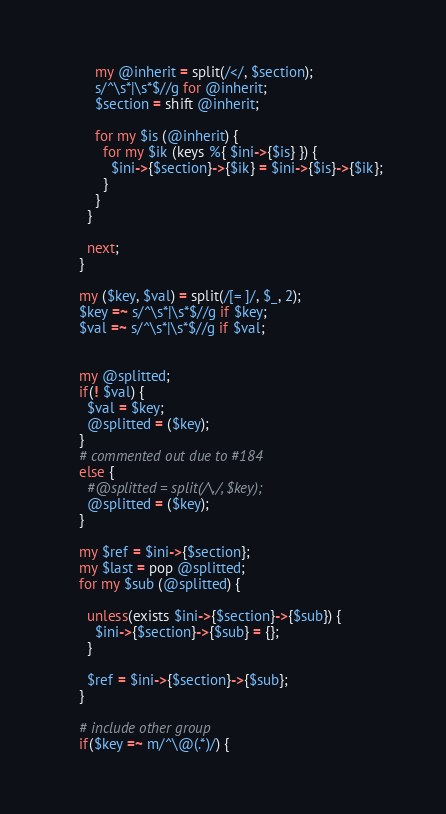Convert code to text. <code><loc_0><loc_0><loc_500><loc_500><_Perl_>        my @inherit = split(/</, $section);
        s/^\s*|\s*$//g for @inherit;
        $section = shift @inherit;

        for my $is (@inherit) {
          for my $ik (keys %{ $ini->{$is} }) {
            $ini->{$section}->{$ik} = $ini->{$is}->{$ik};
          }
        }
      }

      next;
    }

    my ($key, $val) = split(/[= ]/, $_, 2);
    $key =~ s/^\s*|\s*$//g if $key;
    $val =~ s/^\s*|\s*$//g if $val;


    my @splitted;
    if(! $val) {
      $val = $key;
      @splitted = ($key);
    }
    # commented out due to #184
    else {
      #@splitted = split(/\./, $key);
      @splitted = ($key);
    }

    my $ref = $ini->{$section};
    my $last = pop @splitted;
    for my $sub (@splitted) {

      unless(exists $ini->{$section}->{$sub}) {
        $ini->{$section}->{$sub} = {};
      }

      $ref = $ini->{$section}->{$sub};
    }

    # include other group
    if($key =~ m/^\@(.*)/) {</code> 